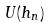<formula> <loc_0><loc_0><loc_500><loc_500>U ( h _ { n } )</formula> 